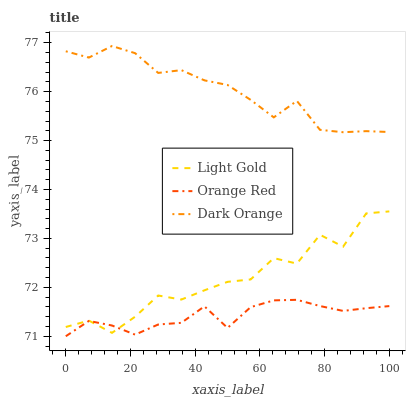Does Orange Red have the minimum area under the curve?
Answer yes or no. Yes. Does Dark Orange have the maximum area under the curve?
Answer yes or no. Yes. Does Light Gold have the minimum area under the curve?
Answer yes or no. No. Does Light Gold have the maximum area under the curve?
Answer yes or no. No. Is Orange Red the smoothest?
Answer yes or no. Yes. Is Light Gold the roughest?
Answer yes or no. Yes. Is Light Gold the smoothest?
Answer yes or no. No. Is Orange Red the roughest?
Answer yes or no. No. Does Orange Red have the lowest value?
Answer yes or no. Yes. Does Light Gold have the lowest value?
Answer yes or no. No. Does Dark Orange have the highest value?
Answer yes or no. Yes. Does Light Gold have the highest value?
Answer yes or no. No. Is Light Gold less than Dark Orange?
Answer yes or no. Yes. Is Dark Orange greater than Light Gold?
Answer yes or no. Yes. Does Orange Red intersect Light Gold?
Answer yes or no. Yes. Is Orange Red less than Light Gold?
Answer yes or no. No. Is Orange Red greater than Light Gold?
Answer yes or no. No. Does Light Gold intersect Dark Orange?
Answer yes or no. No. 